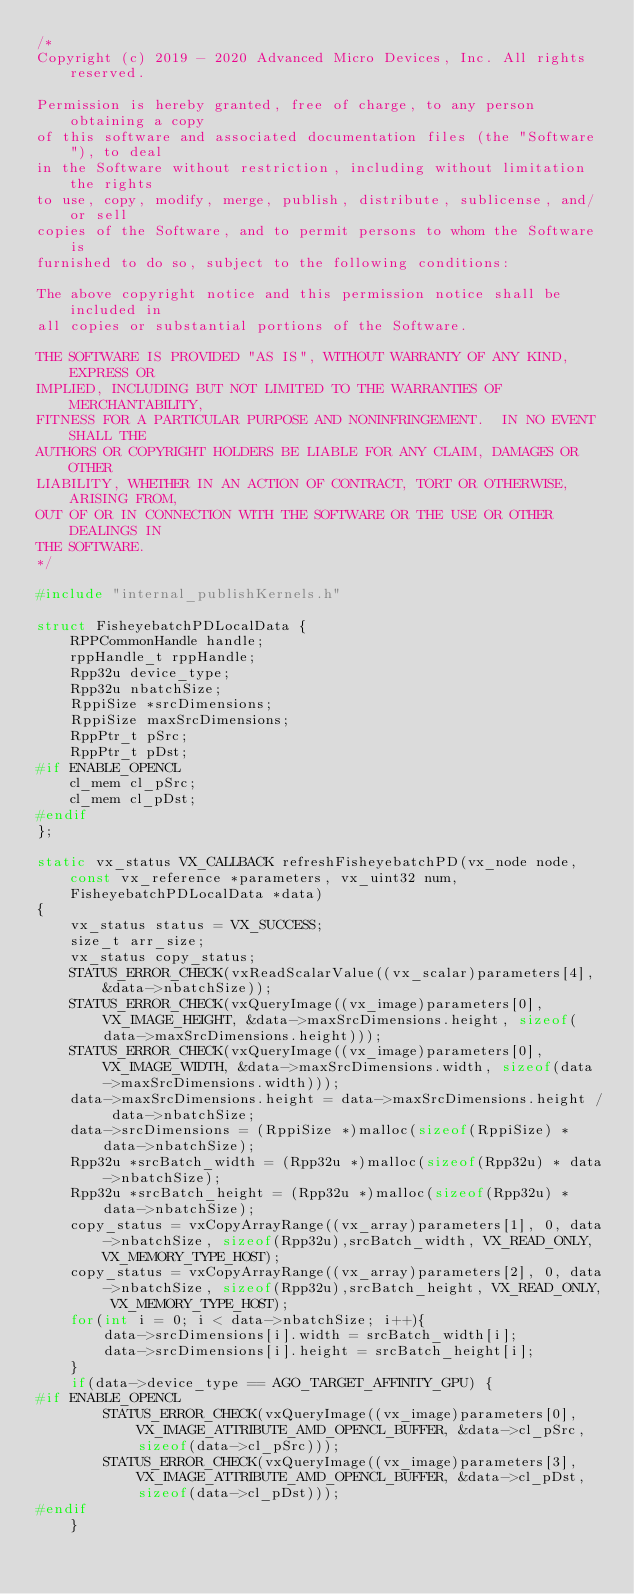Convert code to text. <code><loc_0><loc_0><loc_500><loc_500><_C++_>/*
Copyright (c) 2019 - 2020 Advanced Micro Devices, Inc. All rights reserved.

Permission is hereby granted, free of charge, to any person obtaining a copy
of this software and associated documentation files (the "Software"), to deal
in the Software without restriction, including without limitation the rights
to use, copy, modify, merge, publish, distribute, sublicense, and/or sell
copies of the Software, and to permit persons to whom the Software is
furnished to do so, subject to the following conditions:

The above copyright notice and this permission notice shall be included in
all copies or substantial portions of the Software.

THE SOFTWARE IS PROVIDED "AS IS", WITHOUT WARRANTY OF ANY KIND, EXPRESS OR
IMPLIED, INCLUDING BUT NOT LIMITED TO THE WARRANTIES OF MERCHANTABILITY,
FITNESS FOR A PARTICULAR PURPOSE AND NONINFRINGEMENT.  IN NO EVENT SHALL THE
AUTHORS OR COPYRIGHT HOLDERS BE LIABLE FOR ANY CLAIM, DAMAGES OR OTHER
LIABILITY, WHETHER IN AN ACTION OF CONTRACT, TORT OR OTHERWISE, ARISING FROM,
OUT OF OR IN CONNECTION WITH THE SOFTWARE OR THE USE OR OTHER DEALINGS IN
THE SOFTWARE.
*/

#include "internal_publishKernels.h"

struct FisheyebatchPDLocalData { 
	RPPCommonHandle handle;
	rppHandle_t rppHandle;
	Rpp32u device_type; 
	Rpp32u nbatchSize; 
	RppiSize *srcDimensions;
	RppiSize maxSrcDimensions;
	RppPtr_t pSrc;
	RppPtr_t pDst;
#if ENABLE_OPENCL
	cl_mem cl_pSrc;
	cl_mem cl_pDst;
#endif 
};

static vx_status VX_CALLBACK refreshFisheyebatchPD(vx_node node, const vx_reference *parameters, vx_uint32 num, FisheyebatchPDLocalData *data)
{
	vx_status status = VX_SUCCESS;
 	size_t arr_size;
	vx_status copy_status;
	STATUS_ERROR_CHECK(vxReadScalarValue((vx_scalar)parameters[4], &data->nbatchSize));
	STATUS_ERROR_CHECK(vxQueryImage((vx_image)parameters[0], VX_IMAGE_HEIGHT, &data->maxSrcDimensions.height, sizeof(data->maxSrcDimensions.height)));
	STATUS_ERROR_CHECK(vxQueryImage((vx_image)parameters[0], VX_IMAGE_WIDTH, &data->maxSrcDimensions.width, sizeof(data->maxSrcDimensions.width)));
	data->maxSrcDimensions.height = data->maxSrcDimensions.height / data->nbatchSize;
	data->srcDimensions = (RppiSize *)malloc(sizeof(RppiSize) * data->nbatchSize);
	Rpp32u *srcBatch_width = (Rpp32u *)malloc(sizeof(Rpp32u) * data->nbatchSize);
	Rpp32u *srcBatch_height = (Rpp32u *)malloc(sizeof(Rpp32u) * data->nbatchSize);
	copy_status = vxCopyArrayRange((vx_array)parameters[1], 0, data->nbatchSize, sizeof(Rpp32u),srcBatch_width, VX_READ_ONLY, VX_MEMORY_TYPE_HOST);
	copy_status = vxCopyArrayRange((vx_array)parameters[2], 0, data->nbatchSize, sizeof(Rpp32u),srcBatch_height, VX_READ_ONLY, VX_MEMORY_TYPE_HOST);
	for(int i = 0; i < data->nbatchSize; i++){
		data->srcDimensions[i].width = srcBatch_width[i];
		data->srcDimensions[i].height = srcBatch_height[i];
	}
	if(data->device_type == AGO_TARGET_AFFINITY_GPU) {
#if ENABLE_OPENCL
		STATUS_ERROR_CHECK(vxQueryImage((vx_image)parameters[0], VX_IMAGE_ATTRIBUTE_AMD_OPENCL_BUFFER, &data->cl_pSrc, sizeof(data->cl_pSrc)));
		STATUS_ERROR_CHECK(vxQueryImage((vx_image)parameters[3], VX_IMAGE_ATTRIBUTE_AMD_OPENCL_BUFFER, &data->cl_pDst, sizeof(data->cl_pDst)));
#endif
	}</code> 